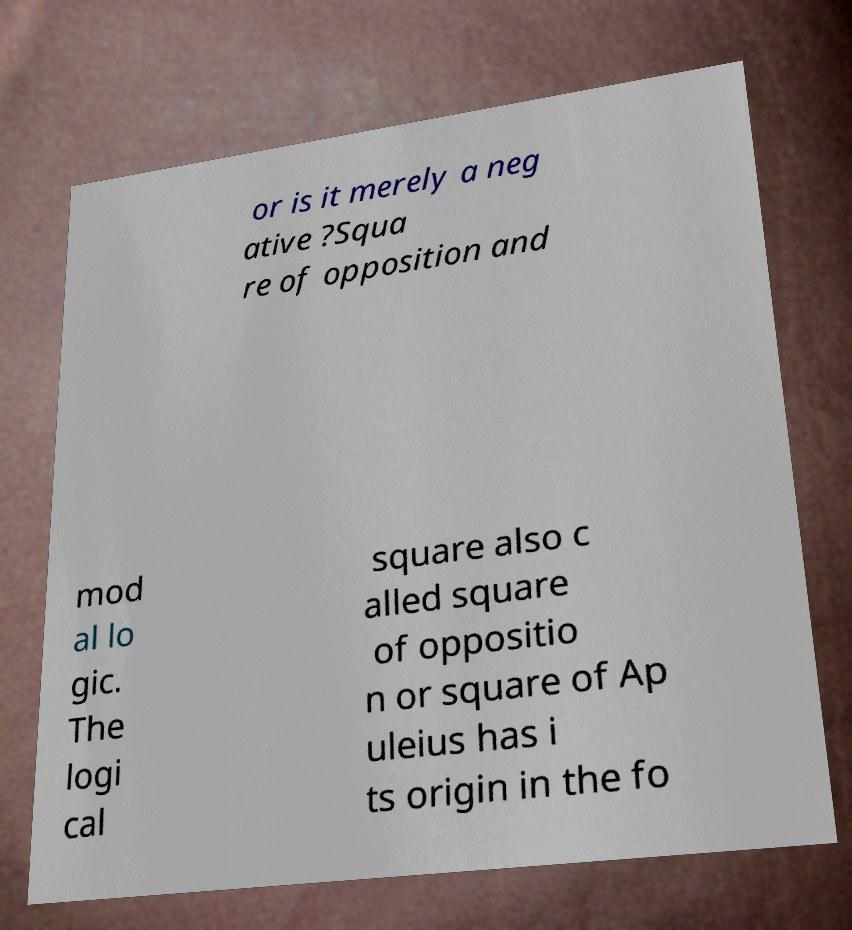For documentation purposes, I need the text within this image transcribed. Could you provide that? or is it merely a neg ative ?Squa re of opposition and mod al lo gic. The logi cal square also c alled square of oppositio n or square of Ap uleius has i ts origin in the fo 